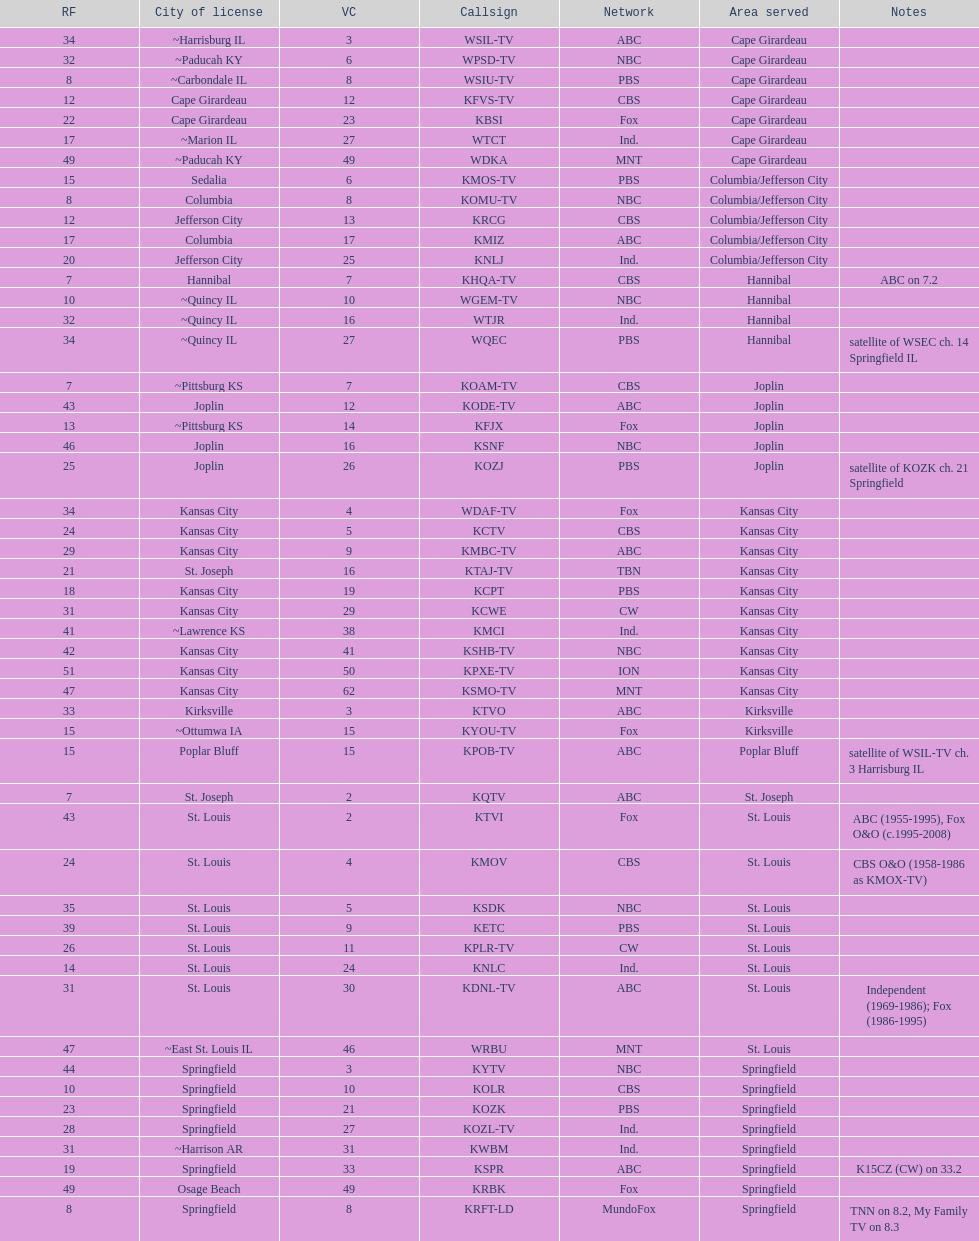What is the total number of stations serving the the cape girardeau area? 7. Could you parse the entire table as a dict? {'header': ['RF', 'City of license', 'VC', 'Callsign', 'Network', 'Area served', 'Notes'], 'rows': [['34', '~Harrisburg IL', '3', 'WSIL-TV', 'ABC', 'Cape Girardeau', ''], ['32', '~Paducah KY', '6', 'WPSD-TV', 'NBC', 'Cape Girardeau', ''], ['8', '~Carbondale IL', '8', 'WSIU-TV', 'PBS', 'Cape Girardeau', ''], ['12', 'Cape Girardeau', '12', 'KFVS-TV', 'CBS', 'Cape Girardeau', ''], ['22', 'Cape Girardeau', '23', 'KBSI', 'Fox', 'Cape Girardeau', ''], ['17', '~Marion IL', '27', 'WTCT', 'Ind.', 'Cape Girardeau', ''], ['49', '~Paducah KY', '49', 'WDKA', 'MNT', 'Cape Girardeau', ''], ['15', 'Sedalia', '6', 'KMOS-TV', 'PBS', 'Columbia/Jefferson City', ''], ['8', 'Columbia', '8', 'KOMU-TV', 'NBC', 'Columbia/Jefferson City', ''], ['12', 'Jefferson City', '13', 'KRCG', 'CBS', 'Columbia/Jefferson City', ''], ['17', 'Columbia', '17', 'KMIZ', 'ABC', 'Columbia/Jefferson City', ''], ['20', 'Jefferson City', '25', 'KNLJ', 'Ind.', 'Columbia/Jefferson City', ''], ['7', 'Hannibal', '7', 'KHQA-TV', 'CBS', 'Hannibal', 'ABC on 7.2'], ['10', '~Quincy IL', '10', 'WGEM-TV', 'NBC', 'Hannibal', ''], ['32', '~Quincy IL', '16', 'WTJR', 'Ind.', 'Hannibal', ''], ['34', '~Quincy IL', '27', 'WQEC', 'PBS', 'Hannibal', 'satellite of WSEC ch. 14 Springfield IL'], ['7', '~Pittsburg KS', '7', 'KOAM-TV', 'CBS', 'Joplin', ''], ['43', 'Joplin', '12', 'KODE-TV', 'ABC', 'Joplin', ''], ['13', '~Pittsburg KS', '14', 'KFJX', 'Fox', 'Joplin', ''], ['46', 'Joplin', '16', 'KSNF', 'NBC', 'Joplin', ''], ['25', 'Joplin', '26', 'KOZJ', 'PBS', 'Joplin', 'satellite of KOZK ch. 21 Springfield'], ['34', 'Kansas City', '4', 'WDAF-TV', 'Fox', 'Kansas City', ''], ['24', 'Kansas City', '5', 'KCTV', 'CBS', 'Kansas City', ''], ['29', 'Kansas City', '9', 'KMBC-TV', 'ABC', 'Kansas City', ''], ['21', 'St. Joseph', '16', 'KTAJ-TV', 'TBN', 'Kansas City', ''], ['18', 'Kansas City', '19', 'KCPT', 'PBS', 'Kansas City', ''], ['31', 'Kansas City', '29', 'KCWE', 'CW', 'Kansas City', ''], ['41', '~Lawrence KS', '38', 'KMCI', 'Ind.', 'Kansas City', ''], ['42', 'Kansas City', '41', 'KSHB-TV', 'NBC', 'Kansas City', ''], ['51', 'Kansas City', '50', 'KPXE-TV', 'ION', 'Kansas City', ''], ['47', 'Kansas City', '62', 'KSMO-TV', 'MNT', 'Kansas City', ''], ['33', 'Kirksville', '3', 'KTVO', 'ABC', 'Kirksville', ''], ['15', '~Ottumwa IA', '15', 'KYOU-TV', 'Fox', 'Kirksville', ''], ['15', 'Poplar Bluff', '15', 'KPOB-TV', 'ABC', 'Poplar Bluff', 'satellite of WSIL-TV ch. 3 Harrisburg IL'], ['7', 'St. Joseph', '2', 'KQTV', 'ABC', 'St. Joseph', ''], ['43', 'St. Louis', '2', 'KTVI', 'Fox', 'St. Louis', 'ABC (1955-1995), Fox O&O (c.1995-2008)'], ['24', 'St. Louis', '4', 'KMOV', 'CBS', 'St. Louis', 'CBS O&O (1958-1986 as KMOX-TV)'], ['35', 'St. Louis', '5', 'KSDK', 'NBC', 'St. Louis', ''], ['39', 'St. Louis', '9', 'KETC', 'PBS', 'St. Louis', ''], ['26', 'St. Louis', '11', 'KPLR-TV', 'CW', 'St. Louis', ''], ['14', 'St. Louis', '24', 'KNLC', 'Ind.', 'St. Louis', ''], ['31', 'St. Louis', '30', 'KDNL-TV', 'ABC', 'St. Louis', 'Independent (1969-1986); Fox (1986-1995)'], ['47', '~East St. Louis IL', '46', 'WRBU', 'MNT', 'St. Louis', ''], ['44', 'Springfield', '3', 'KYTV', 'NBC', 'Springfield', ''], ['10', 'Springfield', '10', 'KOLR', 'CBS', 'Springfield', ''], ['23', 'Springfield', '21', 'KOZK', 'PBS', 'Springfield', ''], ['28', 'Springfield', '27', 'KOZL-TV', 'Ind.', 'Springfield', ''], ['31', '~Harrison AR', '31', 'KWBM', 'Ind.', 'Springfield', ''], ['19', 'Springfield', '33', 'KSPR', 'ABC', 'Springfield', 'K15CZ (CW) on 33.2'], ['49', 'Osage Beach', '49', 'KRBK', 'Fox', 'Springfield', ''], ['8', 'Springfield', '8', 'KRFT-LD', 'MundoFox', 'Springfield', 'TNN on 8.2, My Family TV on 8.3']]} 